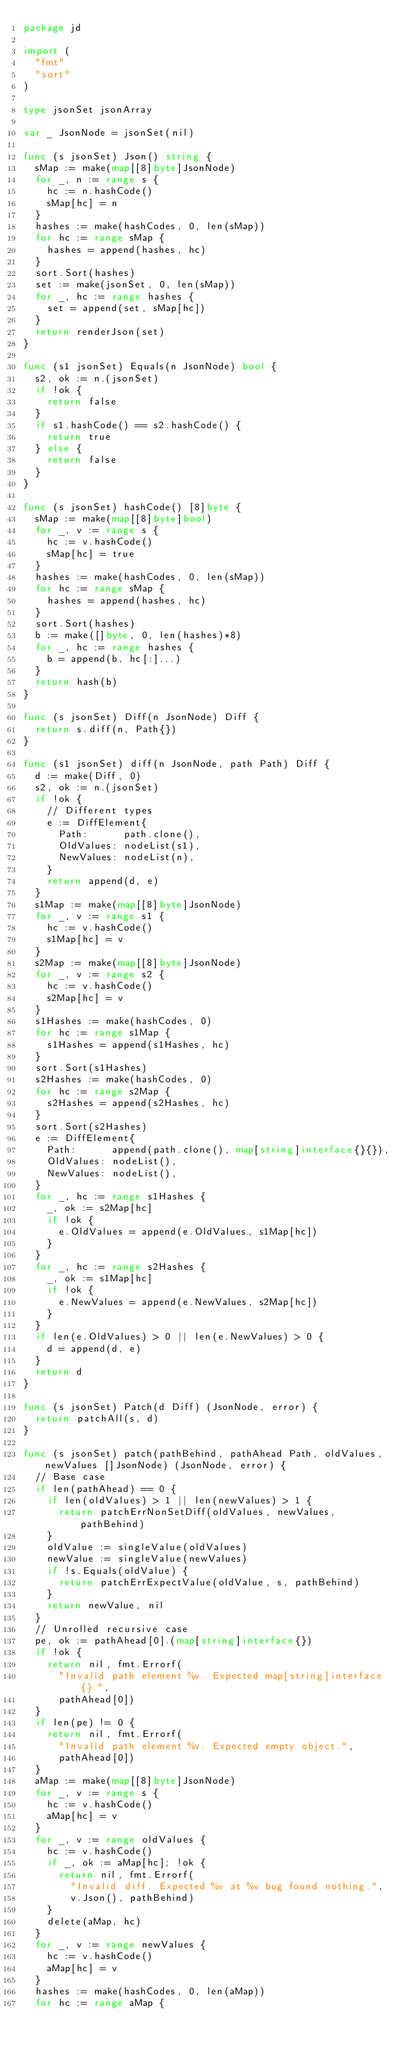<code> <loc_0><loc_0><loc_500><loc_500><_Go_>package jd

import (
	"fmt"
	"sort"
)

type jsonSet jsonArray

var _ JsonNode = jsonSet(nil)

func (s jsonSet) Json() string {
	sMap := make(map[[8]byte]JsonNode)
	for _, n := range s {
		hc := n.hashCode()
		sMap[hc] = n
	}
	hashes := make(hashCodes, 0, len(sMap))
	for hc := range sMap {
		hashes = append(hashes, hc)
	}
	sort.Sort(hashes)
	set := make(jsonSet, 0, len(sMap))
	for _, hc := range hashes {
		set = append(set, sMap[hc])
	}
	return renderJson(set)
}

func (s1 jsonSet) Equals(n JsonNode) bool {
	s2, ok := n.(jsonSet)
	if !ok {
		return false
	}
	if s1.hashCode() == s2.hashCode() {
		return true
	} else {
		return false
	}
}

func (s jsonSet) hashCode() [8]byte {
	sMap := make(map[[8]byte]bool)
	for _, v := range s {
		hc := v.hashCode()
		sMap[hc] = true
	}
	hashes := make(hashCodes, 0, len(sMap))
	for hc := range sMap {
		hashes = append(hashes, hc)
	}
	sort.Sort(hashes)
	b := make([]byte, 0, len(hashes)*8)
	for _, hc := range hashes {
		b = append(b, hc[:]...)
	}
	return hash(b)
}

func (s jsonSet) Diff(n JsonNode) Diff {
	return s.diff(n, Path{})
}

func (s1 jsonSet) diff(n JsonNode, path Path) Diff {
	d := make(Diff, 0)
	s2, ok := n.(jsonSet)
	if !ok {
		// Different types
		e := DiffElement{
			Path:      path.clone(),
			OldValues: nodeList(s1),
			NewValues: nodeList(n),
		}
		return append(d, e)
	}
	s1Map := make(map[[8]byte]JsonNode)
	for _, v := range s1 {
		hc := v.hashCode()
		s1Map[hc] = v
	}
	s2Map := make(map[[8]byte]JsonNode)
	for _, v := range s2 {
		hc := v.hashCode()
		s2Map[hc] = v
	}
	s1Hashes := make(hashCodes, 0)
	for hc := range s1Map {
		s1Hashes = append(s1Hashes, hc)
	}
	sort.Sort(s1Hashes)
	s2Hashes := make(hashCodes, 0)
	for hc := range s2Map {
		s2Hashes = append(s2Hashes, hc)
	}
	sort.Sort(s2Hashes)
	e := DiffElement{
		Path:      append(path.clone(), map[string]interface{}{}),
		OldValues: nodeList(),
		NewValues: nodeList(),
	}
	for _, hc := range s1Hashes {
		_, ok := s2Map[hc]
		if !ok {
			e.OldValues = append(e.OldValues, s1Map[hc])
		}
	}
	for _, hc := range s2Hashes {
		_, ok := s1Map[hc]
		if !ok {
			e.NewValues = append(e.NewValues, s2Map[hc])
		}
	}
	if len(e.OldValues) > 0 || len(e.NewValues) > 0 {
		d = append(d, e)
	}
	return d
}

func (s jsonSet) Patch(d Diff) (JsonNode, error) {
	return patchAll(s, d)
}

func (s jsonSet) patch(pathBehind, pathAhead Path, oldValues, newValues []JsonNode) (JsonNode, error) {
	// Base case
	if len(pathAhead) == 0 {
		if len(oldValues) > 1 || len(newValues) > 1 {
			return patchErrNonSetDiff(oldValues, newValues, pathBehind)
		}
		oldValue := singleValue(oldValues)
		newValue := singleValue(newValues)
		if !s.Equals(oldValue) {
			return patchErrExpectValue(oldValue, s, pathBehind)
		}
		return newValue, nil
	}
	// Unrolled recursive case
	pe, ok := pathAhead[0].(map[string]interface{})
	if !ok {
		return nil, fmt.Errorf(
			"Invalid path element %v. Expected map[string]interface{}.",
			pathAhead[0])
	}
	if len(pe) != 0 {
		return nil, fmt.Errorf(
			"Invalid path element %v. Expected empty object.",
			pathAhead[0])
	}
	aMap := make(map[[8]byte]JsonNode)
	for _, v := range s {
		hc := v.hashCode()
		aMap[hc] = v
	}
	for _, v := range oldValues {
		hc := v.hashCode()
		if _, ok := aMap[hc]; !ok {
			return nil, fmt.Errorf(
				"Invalid diff. Expected %v at %v bug found nothing.",
				v.Json(), pathBehind)
		}
		delete(aMap, hc)
	}
	for _, v := range newValues {
		hc := v.hashCode()
		aMap[hc] = v
	}
	hashes := make(hashCodes, 0, len(aMap))
	for hc := range aMap {</code> 